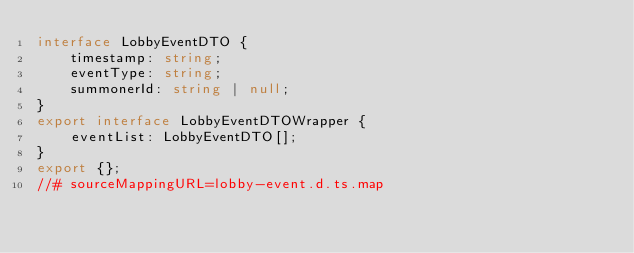Convert code to text. <code><loc_0><loc_0><loc_500><loc_500><_TypeScript_>interface LobbyEventDTO {
    timestamp: string;
    eventType: string;
    summonerId: string | null;
}
export interface LobbyEventDTOWrapper {
    eventList: LobbyEventDTO[];
}
export {};
//# sourceMappingURL=lobby-event.d.ts.map</code> 